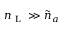<formula> <loc_0><loc_0><loc_500><loc_500>{ n } _ { L } \gg \tilde { n } _ { a }</formula> 